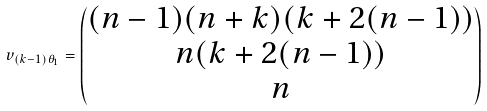Convert formula to latex. <formula><loc_0><loc_0><loc_500><loc_500>v _ { ( k - 1 ) \theta _ { 1 } } = \begin{pmatrix} ( n - 1 ) ( n + k ) ( k + 2 ( n - 1 ) ) \\ n ( k + 2 ( n - 1 ) ) \\ n \end{pmatrix}</formula> 